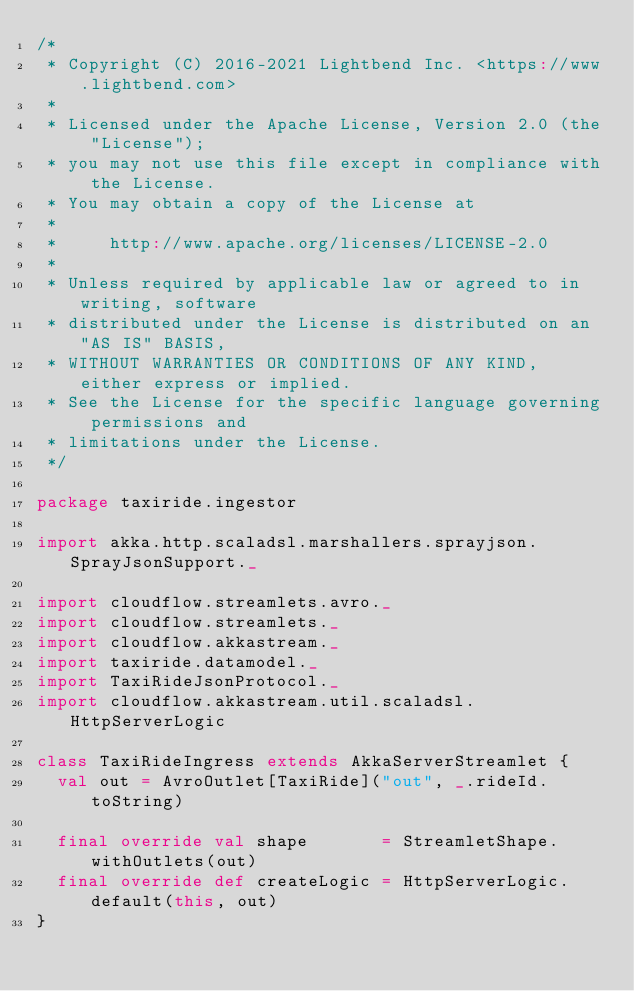<code> <loc_0><loc_0><loc_500><loc_500><_Scala_>/*
 * Copyright (C) 2016-2021 Lightbend Inc. <https://www.lightbend.com>
 *
 * Licensed under the Apache License, Version 2.0 (the "License");
 * you may not use this file except in compliance with the License.
 * You may obtain a copy of the License at
 *
 *     http://www.apache.org/licenses/LICENSE-2.0
 *
 * Unless required by applicable law or agreed to in writing, software
 * distributed under the License is distributed on an "AS IS" BASIS,
 * WITHOUT WARRANTIES OR CONDITIONS OF ANY KIND, either express or implied.
 * See the License for the specific language governing permissions and
 * limitations under the License.
 */

package taxiride.ingestor

import akka.http.scaladsl.marshallers.sprayjson.SprayJsonSupport._

import cloudflow.streamlets.avro._
import cloudflow.streamlets._
import cloudflow.akkastream._
import taxiride.datamodel._
import TaxiRideJsonProtocol._
import cloudflow.akkastream.util.scaladsl.HttpServerLogic

class TaxiRideIngress extends AkkaServerStreamlet {
  val out = AvroOutlet[TaxiRide]("out", _.rideId.toString)

  final override val shape       = StreamletShape.withOutlets(out)
  final override def createLogic = HttpServerLogic.default(this, out)
}
</code> 